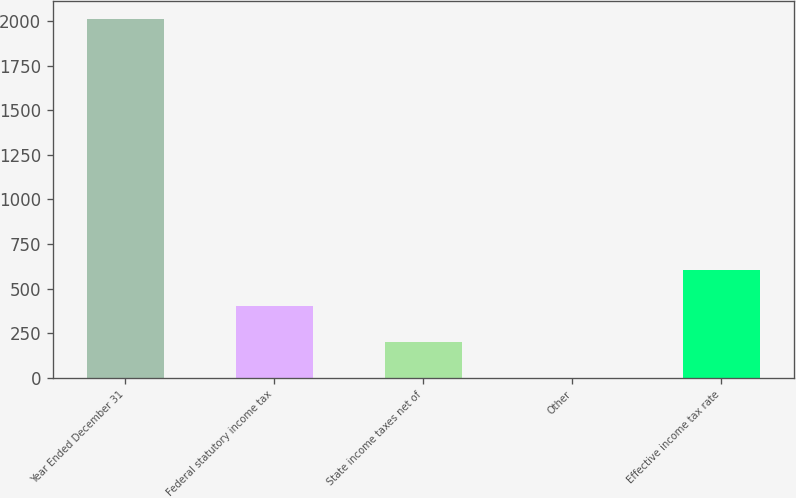<chart> <loc_0><loc_0><loc_500><loc_500><bar_chart><fcel>Year Ended December 31<fcel>Federal statutory income tax<fcel>State income taxes net of<fcel>Other<fcel>Effective income tax rate<nl><fcel>2015<fcel>403.88<fcel>202.49<fcel>1.1<fcel>605.27<nl></chart> 